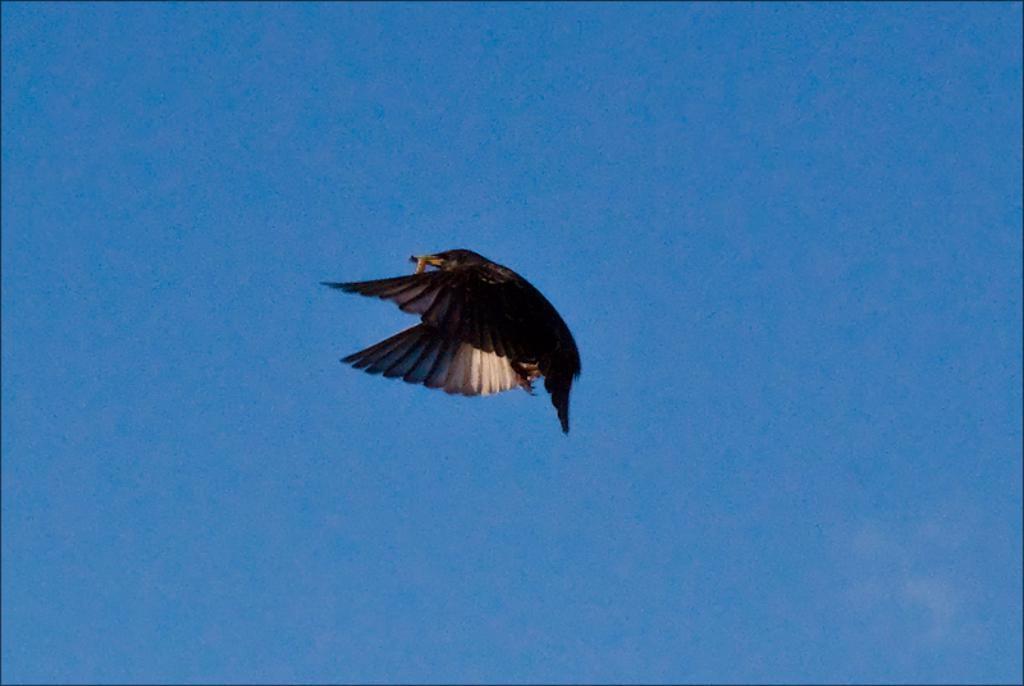In one or two sentences, can you explain what this image depicts? In this image, we can see a bird is flying in the air. In the background we can see the sky. 